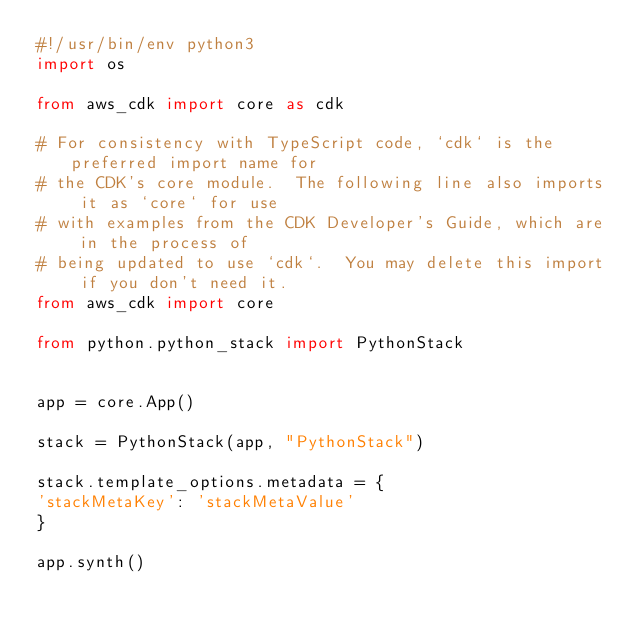Convert code to text. <code><loc_0><loc_0><loc_500><loc_500><_Python_>#!/usr/bin/env python3
import os

from aws_cdk import core as cdk

# For consistency with TypeScript code, `cdk` is the preferred import name for
# the CDK's core module.  The following line also imports it as `core` for use
# with examples from the CDK Developer's Guide, which are in the process of
# being updated to use `cdk`.  You may delete this import if you don't need it.
from aws_cdk import core

from python.python_stack import PythonStack


app = core.App()

stack = PythonStack(app, "PythonStack")

stack.template_options.metadata = {
'stackMetaKey': 'stackMetaValue'
}

app.synth()
</code> 